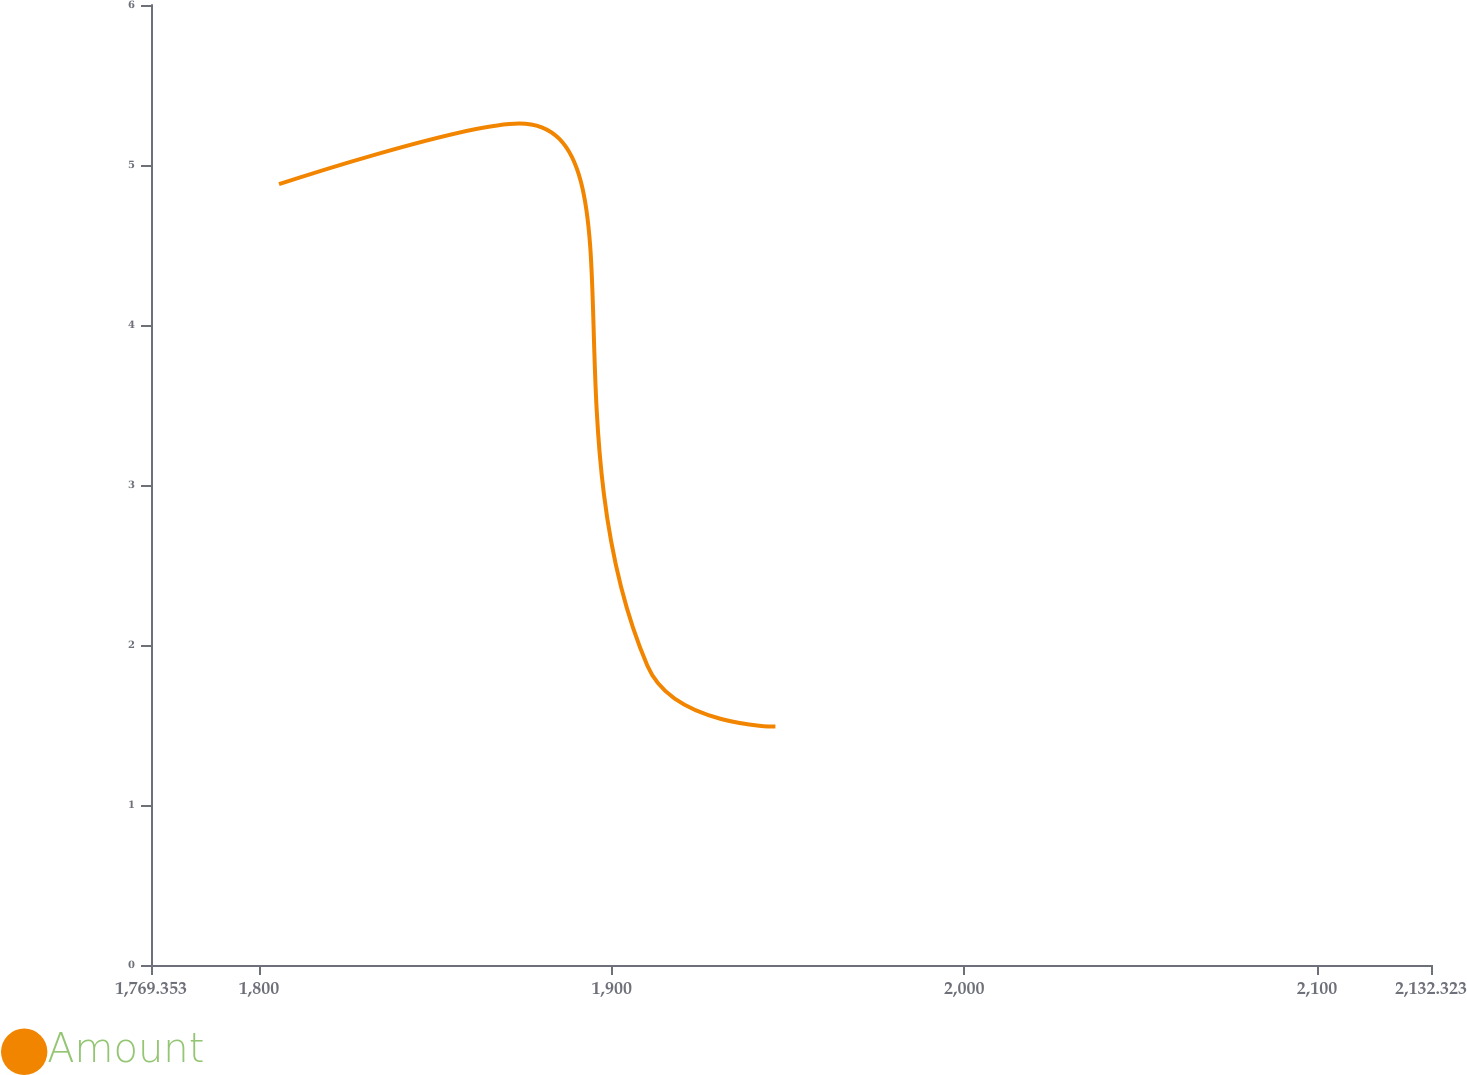Convert chart to OTSL. <chart><loc_0><loc_0><loc_500><loc_500><line_chart><ecel><fcel>Amount<nl><fcel>1805.65<fcel>4.88<nl><fcel>1873.82<fcel>5.26<nl><fcel>1910.12<fcel>1.87<nl><fcel>1946.42<fcel>1.49<nl><fcel>2168.62<fcel>1.11<nl></chart> 